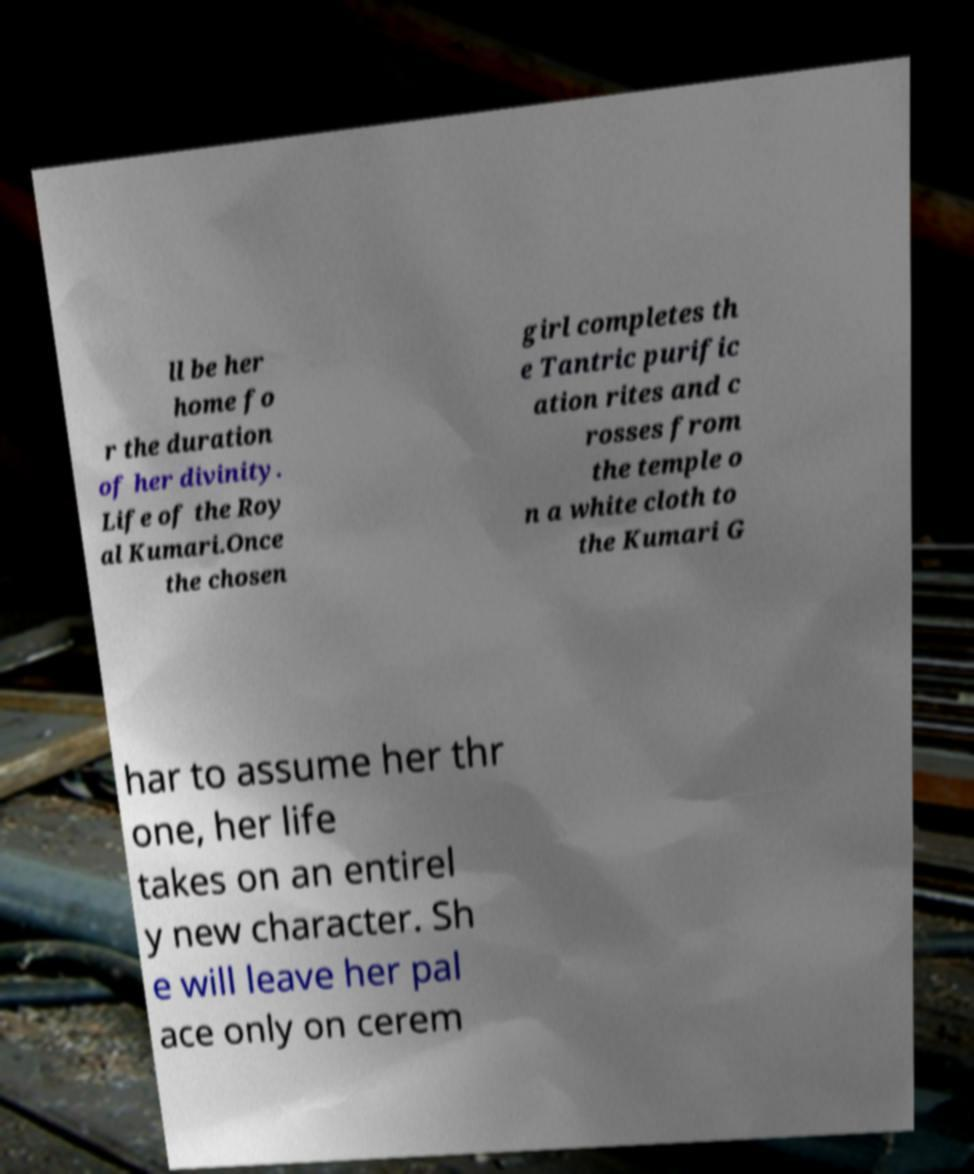Could you extract and type out the text from this image? ll be her home fo r the duration of her divinity. Life of the Roy al Kumari.Once the chosen girl completes th e Tantric purific ation rites and c rosses from the temple o n a white cloth to the Kumari G har to assume her thr one, her life takes on an entirel y new character. Sh e will leave her pal ace only on cerem 